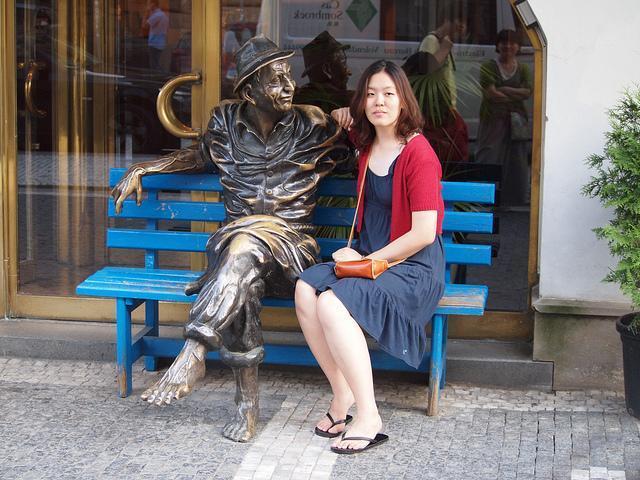How many people can be seen?
Give a very brief answer. 4. 